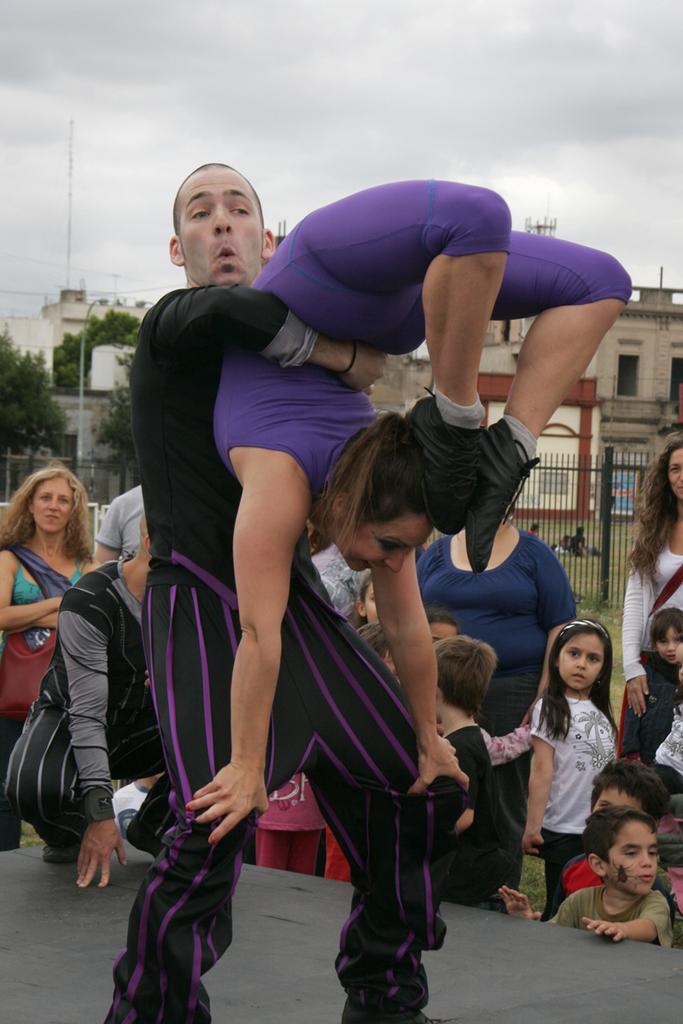Describe this image in one or two sentences. In this image in the foreground there is one man, who is lifting one woman and in the background there are group of people and some children. At the bottom there is some board, and in the background there is gate, buildings, trees, poles, and some wires. At the top there is sky. 